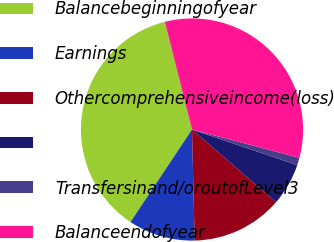Convert chart to OTSL. <chart><loc_0><loc_0><loc_500><loc_500><pie_chart><fcel>Balancebeginningofyear<fcel>Earnings<fcel>Othercomprehensiveincome(loss)<fcel>Unnamed: 3<fcel>Transfersinand/oroutofLevel3<fcel>Balanceendofyear<nl><fcel>36.73%<fcel>9.72%<fcel>13.28%<fcel>6.15%<fcel>1.09%<fcel>33.03%<nl></chart> 